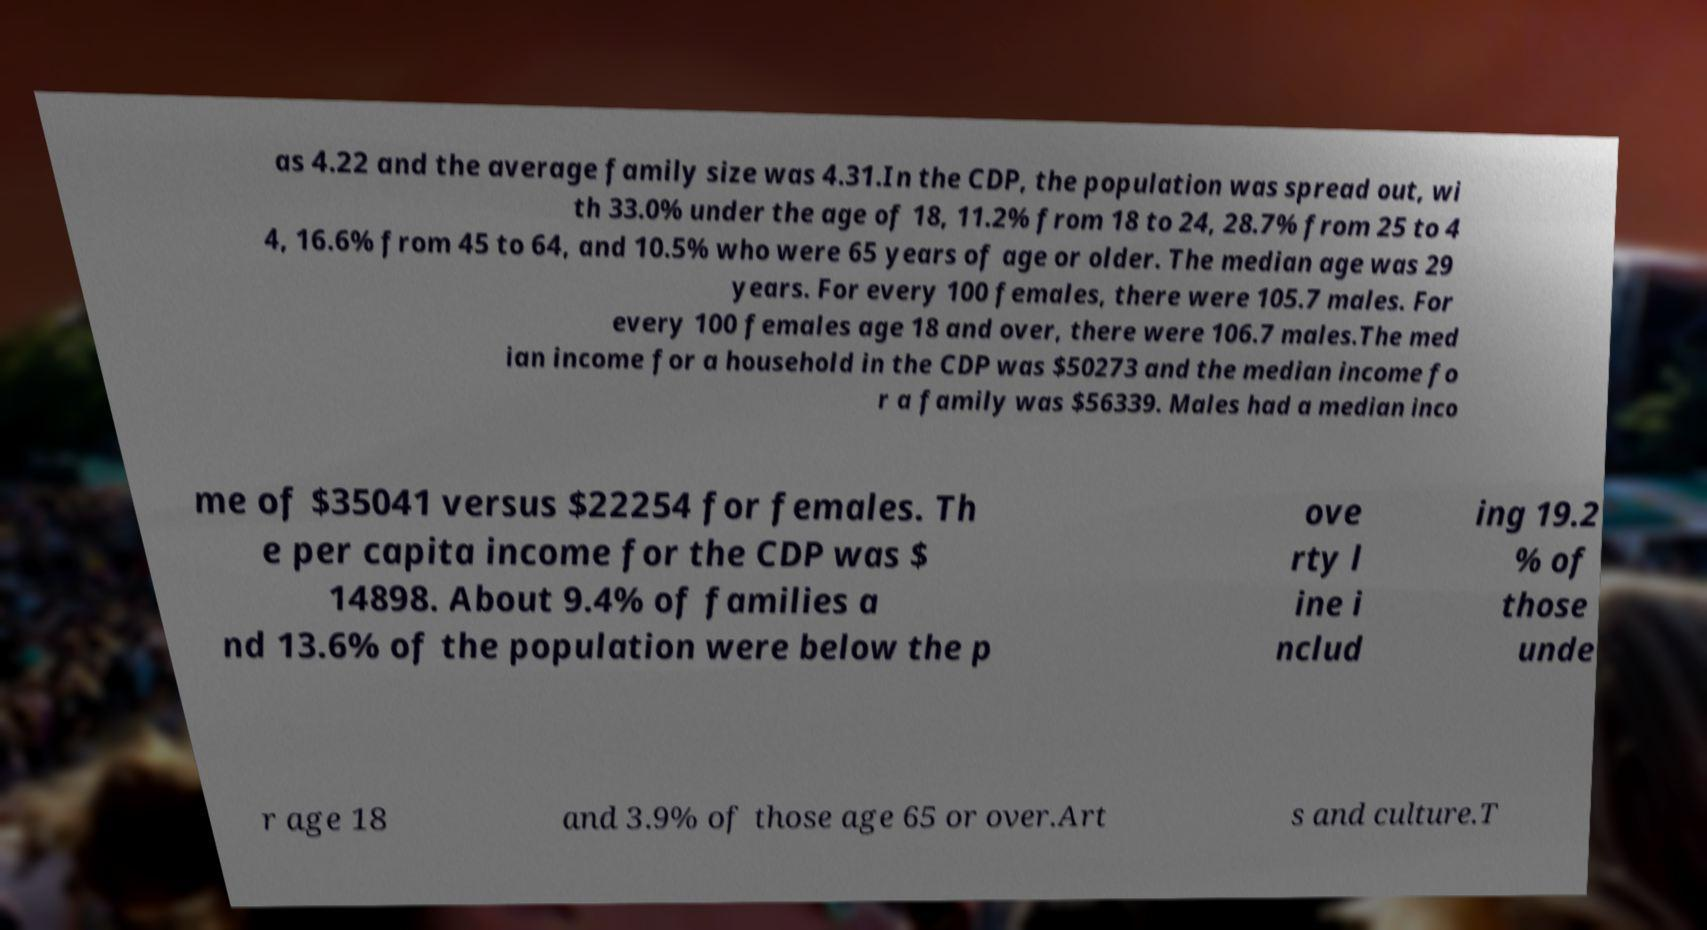Could you extract and type out the text from this image? as 4.22 and the average family size was 4.31.In the CDP, the population was spread out, wi th 33.0% under the age of 18, 11.2% from 18 to 24, 28.7% from 25 to 4 4, 16.6% from 45 to 64, and 10.5% who were 65 years of age or older. The median age was 29 years. For every 100 females, there were 105.7 males. For every 100 females age 18 and over, there were 106.7 males.The med ian income for a household in the CDP was $50273 and the median income fo r a family was $56339. Males had a median inco me of $35041 versus $22254 for females. Th e per capita income for the CDP was $ 14898. About 9.4% of families a nd 13.6% of the population were below the p ove rty l ine i nclud ing 19.2 % of those unde r age 18 and 3.9% of those age 65 or over.Art s and culture.T 